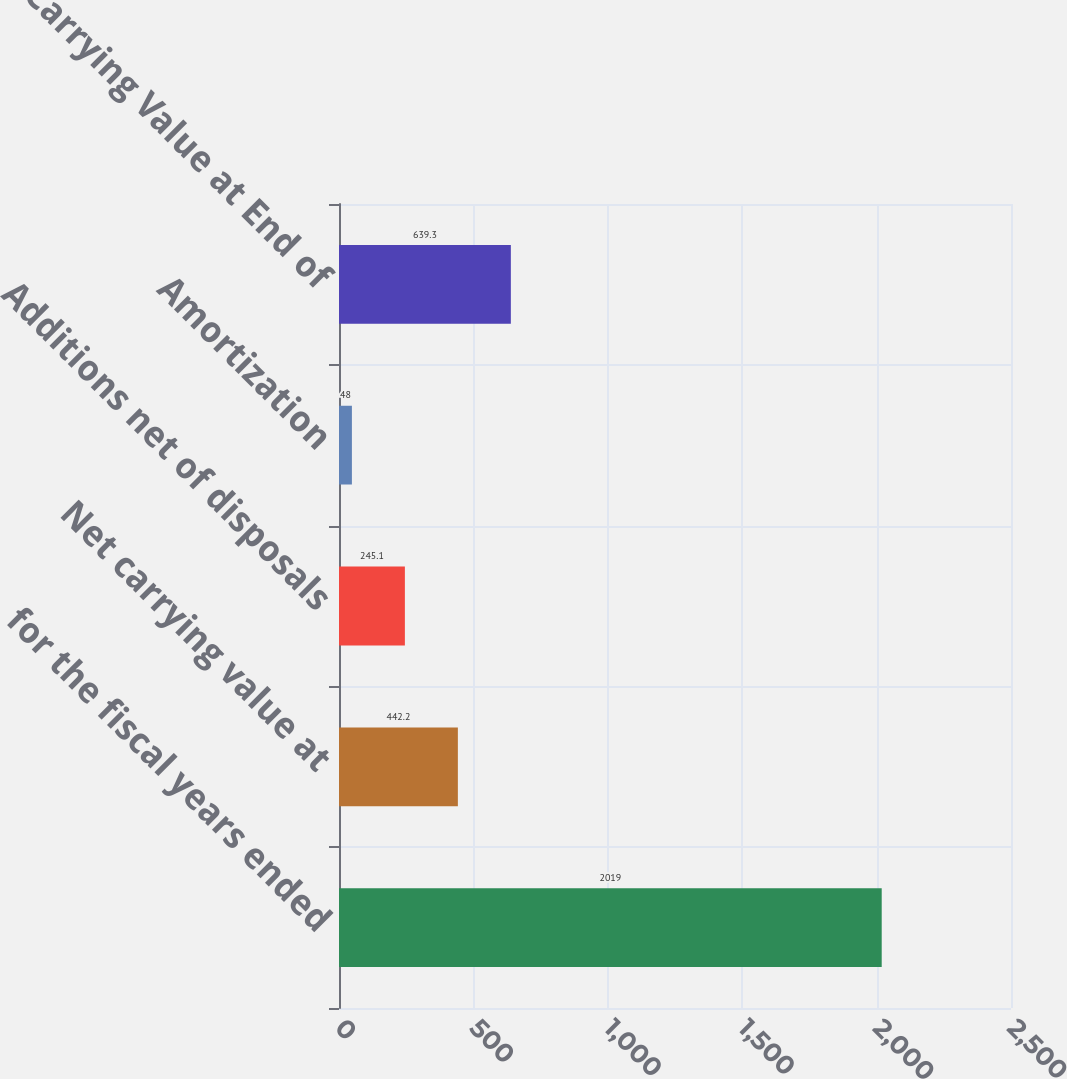<chart> <loc_0><loc_0><loc_500><loc_500><bar_chart><fcel>for the fiscal years ended<fcel>Net carrying value at<fcel>Additions net of disposals<fcel>Amortization<fcel>Net Carrying Value at End of<nl><fcel>2019<fcel>442.2<fcel>245.1<fcel>48<fcel>639.3<nl></chart> 